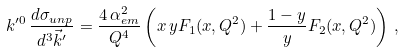<formula> <loc_0><loc_0><loc_500><loc_500>k ^ { \prime 0 } \, \frac { d \sigma _ { u n p } } { d ^ { 3 } \vec { k } ^ { \prime } } = \frac { 4 \, \alpha _ { e m } ^ { 2 } } { Q ^ { 4 } } \left ( x \, y F _ { 1 } ( x , Q ^ { 2 } ) + \frac { 1 - y } { y } F _ { 2 } ( x , Q ^ { 2 } ) \right ) \, ,</formula> 